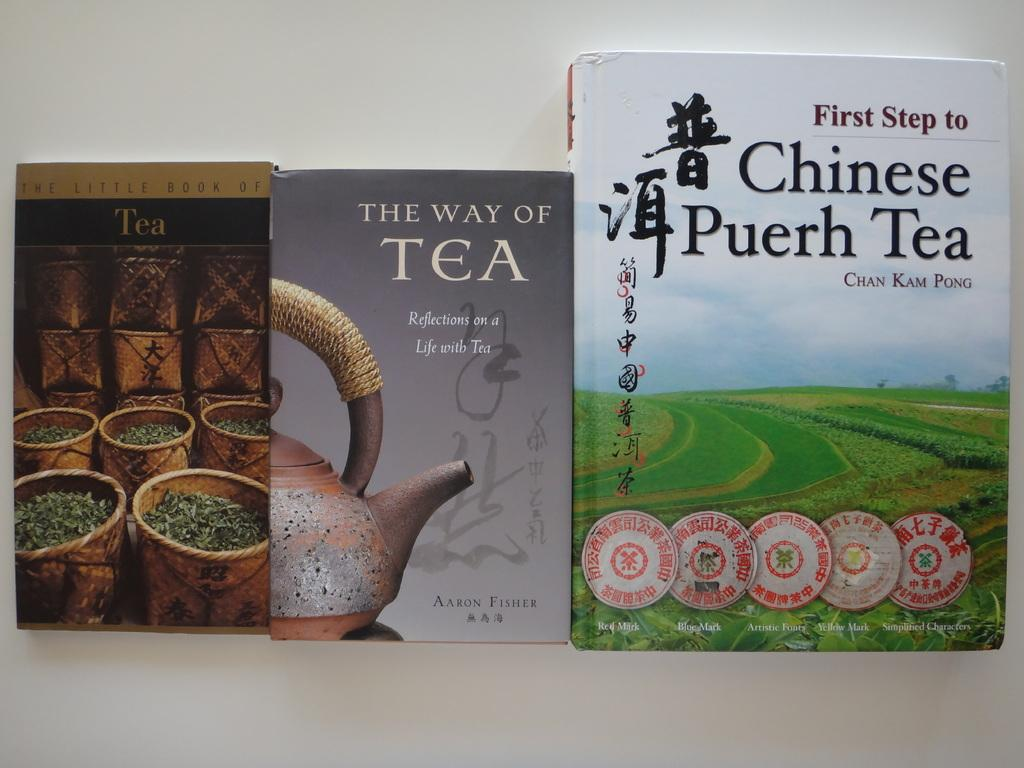<image>
Present a compact description of the photo's key features. A book titled The Way of Tea in between two other books. 